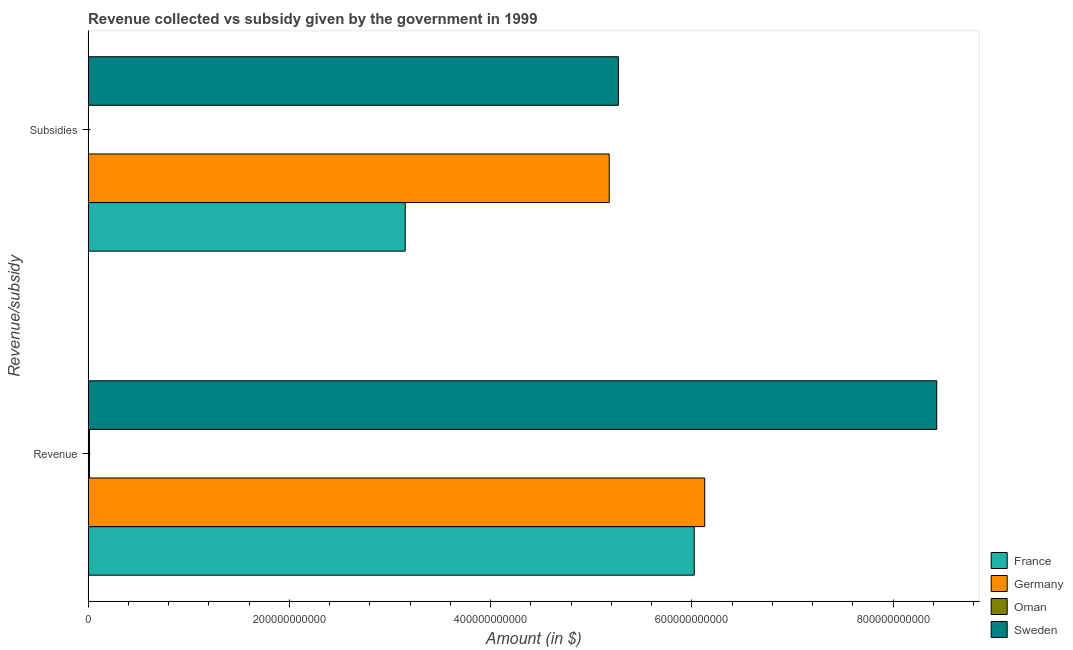How many different coloured bars are there?
Offer a very short reply. 4. How many groups of bars are there?
Give a very brief answer. 2. Are the number of bars on each tick of the Y-axis equal?
Your answer should be compact. Yes. How many bars are there on the 1st tick from the bottom?
Ensure brevity in your answer.  4. What is the label of the 2nd group of bars from the top?
Keep it short and to the point. Revenue. What is the amount of subsidies given in Germany?
Provide a succinct answer. 5.18e+11. Across all countries, what is the maximum amount of revenue collected?
Make the answer very short. 8.43e+11. Across all countries, what is the minimum amount of subsidies given?
Give a very brief answer. 1.95e+08. In which country was the amount of subsidies given minimum?
Keep it short and to the point. Oman. What is the total amount of subsidies given in the graph?
Provide a succinct answer. 1.36e+12. What is the difference between the amount of revenue collected in Germany and that in France?
Your response must be concise. 1.04e+1. What is the difference between the amount of revenue collected in Sweden and the amount of subsidies given in France?
Keep it short and to the point. 5.28e+11. What is the average amount of revenue collected per country?
Ensure brevity in your answer.  5.15e+11. What is the difference between the amount of revenue collected and amount of subsidies given in Oman?
Provide a succinct answer. 1.20e+09. In how many countries, is the amount of subsidies given greater than 280000000000 $?
Provide a succinct answer. 3. What is the ratio of the amount of subsidies given in Sweden to that in Germany?
Offer a very short reply. 1.02. What does the 4th bar from the top in Revenue represents?
Make the answer very short. France. How many bars are there?
Offer a terse response. 8. Are all the bars in the graph horizontal?
Make the answer very short. Yes. What is the difference between two consecutive major ticks on the X-axis?
Your response must be concise. 2.00e+11. Does the graph contain any zero values?
Offer a terse response. No. Does the graph contain grids?
Provide a short and direct response. No. Where does the legend appear in the graph?
Keep it short and to the point. Bottom right. How are the legend labels stacked?
Make the answer very short. Vertical. What is the title of the graph?
Your response must be concise. Revenue collected vs subsidy given by the government in 1999. Does "Eritrea" appear as one of the legend labels in the graph?
Ensure brevity in your answer.  No. What is the label or title of the X-axis?
Provide a short and direct response. Amount (in $). What is the label or title of the Y-axis?
Provide a succinct answer. Revenue/subsidy. What is the Amount (in $) in France in Revenue?
Give a very brief answer. 6.02e+11. What is the Amount (in $) of Germany in Revenue?
Your response must be concise. 6.13e+11. What is the Amount (in $) of Oman in Revenue?
Give a very brief answer. 1.39e+09. What is the Amount (in $) in Sweden in Revenue?
Provide a succinct answer. 8.43e+11. What is the Amount (in $) of France in Subsidies?
Provide a short and direct response. 3.15e+11. What is the Amount (in $) in Germany in Subsidies?
Your answer should be compact. 5.18e+11. What is the Amount (in $) of Oman in Subsidies?
Make the answer very short. 1.95e+08. What is the Amount (in $) of Sweden in Subsidies?
Your answer should be compact. 5.27e+11. Across all Revenue/subsidy, what is the maximum Amount (in $) in France?
Your answer should be compact. 6.02e+11. Across all Revenue/subsidy, what is the maximum Amount (in $) in Germany?
Offer a very short reply. 6.13e+11. Across all Revenue/subsidy, what is the maximum Amount (in $) in Oman?
Give a very brief answer. 1.39e+09. Across all Revenue/subsidy, what is the maximum Amount (in $) of Sweden?
Your answer should be very brief. 8.43e+11. Across all Revenue/subsidy, what is the minimum Amount (in $) in France?
Your answer should be very brief. 3.15e+11. Across all Revenue/subsidy, what is the minimum Amount (in $) in Germany?
Your response must be concise. 5.18e+11. Across all Revenue/subsidy, what is the minimum Amount (in $) in Oman?
Your response must be concise. 1.95e+08. Across all Revenue/subsidy, what is the minimum Amount (in $) in Sweden?
Your answer should be very brief. 5.27e+11. What is the total Amount (in $) of France in the graph?
Offer a very short reply. 9.18e+11. What is the total Amount (in $) in Germany in the graph?
Make the answer very short. 1.13e+12. What is the total Amount (in $) of Oman in the graph?
Provide a short and direct response. 1.59e+09. What is the total Amount (in $) in Sweden in the graph?
Keep it short and to the point. 1.37e+12. What is the difference between the Amount (in $) in France in Revenue and that in Subsidies?
Provide a short and direct response. 2.87e+11. What is the difference between the Amount (in $) in Germany in Revenue and that in Subsidies?
Ensure brevity in your answer.  9.49e+1. What is the difference between the Amount (in $) in Oman in Revenue and that in Subsidies?
Offer a terse response. 1.20e+09. What is the difference between the Amount (in $) in Sweden in Revenue and that in Subsidies?
Ensure brevity in your answer.  3.16e+11. What is the difference between the Amount (in $) in France in Revenue and the Amount (in $) in Germany in Subsidies?
Give a very brief answer. 8.45e+1. What is the difference between the Amount (in $) of France in Revenue and the Amount (in $) of Oman in Subsidies?
Keep it short and to the point. 6.02e+11. What is the difference between the Amount (in $) of France in Revenue and the Amount (in $) of Sweden in Subsidies?
Provide a succinct answer. 7.54e+1. What is the difference between the Amount (in $) of Germany in Revenue and the Amount (in $) of Oman in Subsidies?
Keep it short and to the point. 6.13e+11. What is the difference between the Amount (in $) in Germany in Revenue and the Amount (in $) in Sweden in Subsidies?
Give a very brief answer. 8.58e+1. What is the difference between the Amount (in $) in Oman in Revenue and the Amount (in $) in Sweden in Subsidies?
Provide a succinct answer. -5.26e+11. What is the average Amount (in $) of France per Revenue/subsidy?
Ensure brevity in your answer.  4.59e+11. What is the average Amount (in $) of Germany per Revenue/subsidy?
Provide a succinct answer. 5.65e+11. What is the average Amount (in $) of Oman per Revenue/subsidy?
Offer a very short reply. 7.95e+08. What is the average Amount (in $) in Sweden per Revenue/subsidy?
Ensure brevity in your answer.  6.85e+11. What is the difference between the Amount (in $) in France and Amount (in $) in Germany in Revenue?
Provide a succinct answer. -1.04e+1. What is the difference between the Amount (in $) in France and Amount (in $) in Oman in Revenue?
Your answer should be compact. 6.01e+11. What is the difference between the Amount (in $) in France and Amount (in $) in Sweden in Revenue?
Give a very brief answer. -2.41e+11. What is the difference between the Amount (in $) of Germany and Amount (in $) of Oman in Revenue?
Keep it short and to the point. 6.11e+11. What is the difference between the Amount (in $) of Germany and Amount (in $) of Sweden in Revenue?
Your answer should be very brief. -2.31e+11. What is the difference between the Amount (in $) of Oman and Amount (in $) of Sweden in Revenue?
Give a very brief answer. -8.42e+11. What is the difference between the Amount (in $) of France and Amount (in $) of Germany in Subsidies?
Keep it short and to the point. -2.03e+11. What is the difference between the Amount (in $) of France and Amount (in $) of Oman in Subsidies?
Make the answer very short. 3.15e+11. What is the difference between the Amount (in $) of France and Amount (in $) of Sweden in Subsidies?
Make the answer very short. -2.12e+11. What is the difference between the Amount (in $) in Germany and Amount (in $) in Oman in Subsidies?
Offer a very short reply. 5.18e+11. What is the difference between the Amount (in $) in Germany and Amount (in $) in Sweden in Subsidies?
Make the answer very short. -9.14e+09. What is the difference between the Amount (in $) in Oman and Amount (in $) in Sweden in Subsidies?
Ensure brevity in your answer.  -5.27e+11. What is the ratio of the Amount (in $) in France in Revenue to that in Subsidies?
Give a very brief answer. 1.91. What is the ratio of the Amount (in $) of Germany in Revenue to that in Subsidies?
Offer a terse response. 1.18. What is the ratio of the Amount (in $) in Oman in Revenue to that in Subsidies?
Your answer should be compact. 7.15. What is the ratio of the Amount (in $) in Sweden in Revenue to that in Subsidies?
Keep it short and to the point. 1.6. What is the difference between the highest and the second highest Amount (in $) of France?
Offer a very short reply. 2.87e+11. What is the difference between the highest and the second highest Amount (in $) of Germany?
Provide a succinct answer. 9.49e+1. What is the difference between the highest and the second highest Amount (in $) of Oman?
Offer a very short reply. 1.20e+09. What is the difference between the highest and the second highest Amount (in $) of Sweden?
Make the answer very short. 3.16e+11. What is the difference between the highest and the lowest Amount (in $) in France?
Offer a terse response. 2.87e+11. What is the difference between the highest and the lowest Amount (in $) of Germany?
Ensure brevity in your answer.  9.49e+1. What is the difference between the highest and the lowest Amount (in $) of Oman?
Keep it short and to the point. 1.20e+09. What is the difference between the highest and the lowest Amount (in $) in Sweden?
Provide a short and direct response. 3.16e+11. 